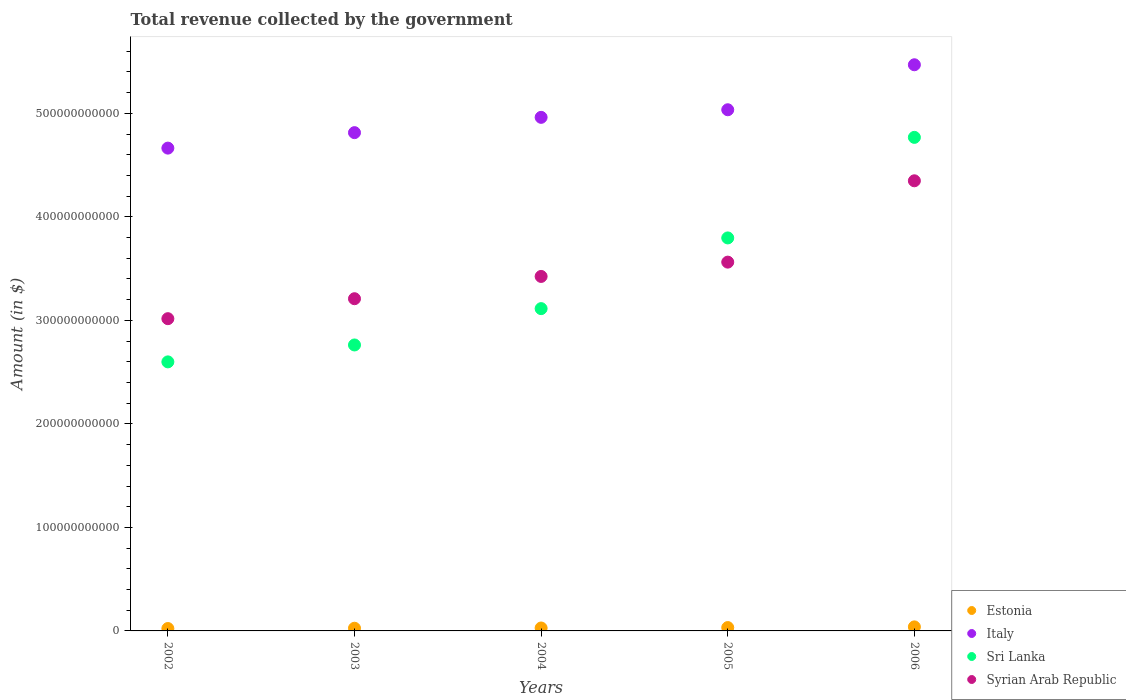How many different coloured dotlines are there?
Ensure brevity in your answer.  4. Is the number of dotlines equal to the number of legend labels?
Give a very brief answer. Yes. What is the total revenue collected by the government in Estonia in 2005?
Give a very brief answer. 3.24e+09. Across all years, what is the maximum total revenue collected by the government in Italy?
Your response must be concise. 5.47e+11. Across all years, what is the minimum total revenue collected by the government in Sri Lanka?
Give a very brief answer. 2.60e+11. In which year was the total revenue collected by the government in Italy maximum?
Provide a succinct answer. 2006. In which year was the total revenue collected by the government in Sri Lanka minimum?
Your answer should be very brief. 2002. What is the total total revenue collected by the government in Italy in the graph?
Your answer should be very brief. 2.49e+12. What is the difference between the total revenue collected by the government in Estonia in 2005 and that in 2006?
Offer a very short reply. -6.53e+08. What is the difference between the total revenue collected by the government in Italy in 2004 and the total revenue collected by the government in Syrian Arab Republic in 2002?
Offer a very short reply. 1.95e+11. What is the average total revenue collected by the government in Sri Lanka per year?
Your answer should be compact. 3.41e+11. In the year 2006, what is the difference between the total revenue collected by the government in Estonia and total revenue collected by the government in Sri Lanka?
Offer a very short reply. -4.73e+11. In how many years, is the total revenue collected by the government in Estonia greater than 40000000000 $?
Provide a succinct answer. 0. What is the ratio of the total revenue collected by the government in Sri Lanka in 2004 to that in 2006?
Give a very brief answer. 0.65. Is the total revenue collected by the government in Syrian Arab Republic in 2003 less than that in 2005?
Ensure brevity in your answer.  Yes. What is the difference between the highest and the second highest total revenue collected by the government in Sri Lanka?
Offer a terse response. 9.72e+1. What is the difference between the highest and the lowest total revenue collected by the government in Estonia?
Ensure brevity in your answer.  1.58e+09. Is the sum of the total revenue collected by the government in Syrian Arab Republic in 2004 and 2006 greater than the maximum total revenue collected by the government in Estonia across all years?
Make the answer very short. Yes. Is the total revenue collected by the government in Italy strictly less than the total revenue collected by the government in Sri Lanka over the years?
Keep it short and to the point. No. What is the difference between two consecutive major ticks on the Y-axis?
Offer a terse response. 1.00e+11. Does the graph contain any zero values?
Your answer should be compact. No. Does the graph contain grids?
Your answer should be compact. No. Where does the legend appear in the graph?
Offer a terse response. Bottom right. How are the legend labels stacked?
Provide a short and direct response. Vertical. What is the title of the graph?
Ensure brevity in your answer.  Total revenue collected by the government. What is the label or title of the Y-axis?
Make the answer very short. Amount (in $). What is the Amount (in $) in Estonia in 2002?
Your response must be concise. 2.32e+09. What is the Amount (in $) in Italy in 2002?
Provide a short and direct response. 4.66e+11. What is the Amount (in $) in Sri Lanka in 2002?
Give a very brief answer. 2.60e+11. What is the Amount (in $) of Syrian Arab Republic in 2002?
Offer a terse response. 3.02e+11. What is the Amount (in $) in Estonia in 2003?
Give a very brief answer. 2.60e+09. What is the Amount (in $) of Italy in 2003?
Your answer should be very brief. 4.81e+11. What is the Amount (in $) in Sri Lanka in 2003?
Give a very brief answer. 2.76e+11. What is the Amount (in $) in Syrian Arab Republic in 2003?
Ensure brevity in your answer.  3.21e+11. What is the Amount (in $) of Estonia in 2004?
Give a very brief answer. 2.83e+09. What is the Amount (in $) of Italy in 2004?
Offer a terse response. 4.96e+11. What is the Amount (in $) in Sri Lanka in 2004?
Your answer should be compact. 3.11e+11. What is the Amount (in $) in Syrian Arab Republic in 2004?
Your answer should be compact. 3.42e+11. What is the Amount (in $) of Estonia in 2005?
Make the answer very short. 3.24e+09. What is the Amount (in $) of Italy in 2005?
Offer a very short reply. 5.03e+11. What is the Amount (in $) in Sri Lanka in 2005?
Provide a short and direct response. 3.80e+11. What is the Amount (in $) of Syrian Arab Republic in 2005?
Your answer should be compact. 3.56e+11. What is the Amount (in $) of Estonia in 2006?
Your response must be concise. 3.90e+09. What is the Amount (in $) of Italy in 2006?
Make the answer very short. 5.47e+11. What is the Amount (in $) of Sri Lanka in 2006?
Your answer should be compact. 4.77e+11. What is the Amount (in $) in Syrian Arab Republic in 2006?
Offer a terse response. 4.35e+11. Across all years, what is the maximum Amount (in $) in Estonia?
Provide a succinct answer. 3.90e+09. Across all years, what is the maximum Amount (in $) in Italy?
Offer a very short reply. 5.47e+11. Across all years, what is the maximum Amount (in $) of Sri Lanka?
Your response must be concise. 4.77e+11. Across all years, what is the maximum Amount (in $) of Syrian Arab Republic?
Make the answer very short. 4.35e+11. Across all years, what is the minimum Amount (in $) of Estonia?
Offer a very short reply. 2.32e+09. Across all years, what is the minimum Amount (in $) in Italy?
Provide a succinct answer. 4.66e+11. Across all years, what is the minimum Amount (in $) of Sri Lanka?
Your answer should be very brief. 2.60e+11. Across all years, what is the minimum Amount (in $) of Syrian Arab Republic?
Ensure brevity in your answer.  3.02e+11. What is the total Amount (in $) in Estonia in the graph?
Make the answer very short. 1.49e+1. What is the total Amount (in $) in Italy in the graph?
Keep it short and to the point. 2.49e+12. What is the total Amount (in $) of Sri Lanka in the graph?
Ensure brevity in your answer.  1.70e+12. What is the total Amount (in $) in Syrian Arab Republic in the graph?
Your response must be concise. 1.76e+12. What is the difference between the Amount (in $) of Estonia in 2002 and that in 2003?
Keep it short and to the point. -2.82e+08. What is the difference between the Amount (in $) of Italy in 2002 and that in 2003?
Provide a short and direct response. -1.50e+1. What is the difference between the Amount (in $) of Sri Lanka in 2002 and that in 2003?
Give a very brief answer. -1.63e+1. What is the difference between the Amount (in $) of Syrian Arab Republic in 2002 and that in 2003?
Provide a short and direct response. -1.93e+1. What is the difference between the Amount (in $) in Estonia in 2002 and that in 2004?
Your answer should be compact. -5.18e+08. What is the difference between the Amount (in $) of Italy in 2002 and that in 2004?
Keep it short and to the point. -2.97e+1. What is the difference between the Amount (in $) of Sri Lanka in 2002 and that in 2004?
Your response must be concise. -5.14e+1. What is the difference between the Amount (in $) of Syrian Arab Republic in 2002 and that in 2004?
Keep it short and to the point. -4.08e+1. What is the difference between the Amount (in $) in Estonia in 2002 and that in 2005?
Provide a succinct answer. -9.29e+08. What is the difference between the Amount (in $) in Italy in 2002 and that in 2005?
Provide a succinct answer. -3.71e+1. What is the difference between the Amount (in $) of Sri Lanka in 2002 and that in 2005?
Give a very brief answer. -1.20e+11. What is the difference between the Amount (in $) in Syrian Arab Republic in 2002 and that in 2005?
Ensure brevity in your answer.  -5.46e+1. What is the difference between the Amount (in $) of Estonia in 2002 and that in 2006?
Offer a terse response. -1.58e+09. What is the difference between the Amount (in $) of Italy in 2002 and that in 2006?
Offer a very short reply. -8.05e+1. What is the difference between the Amount (in $) in Sri Lanka in 2002 and that in 2006?
Offer a very short reply. -2.17e+11. What is the difference between the Amount (in $) in Syrian Arab Republic in 2002 and that in 2006?
Offer a terse response. -1.33e+11. What is the difference between the Amount (in $) in Estonia in 2003 and that in 2004?
Make the answer very short. -2.36e+08. What is the difference between the Amount (in $) of Italy in 2003 and that in 2004?
Give a very brief answer. -1.48e+1. What is the difference between the Amount (in $) in Sri Lanka in 2003 and that in 2004?
Your answer should be compact. -3.51e+1. What is the difference between the Amount (in $) of Syrian Arab Republic in 2003 and that in 2004?
Provide a short and direct response. -2.15e+1. What is the difference between the Amount (in $) of Estonia in 2003 and that in 2005?
Give a very brief answer. -6.47e+08. What is the difference between the Amount (in $) in Italy in 2003 and that in 2005?
Your response must be concise. -2.21e+1. What is the difference between the Amount (in $) of Sri Lanka in 2003 and that in 2005?
Give a very brief answer. -1.03e+11. What is the difference between the Amount (in $) of Syrian Arab Republic in 2003 and that in 2005?
Keep it short and to the point. -3.54e+1. What is the difference between the Amount (in $) in Estonia in 2003 and that in 2006?
Keep it short and to the point. -1.30e+09. What is the difference between the Amount (in $) in Italy in 2003 and that in 2006?
Ensure brevity in your answer.  -6.56e+1. What is the difference between the Amount (in $) of Sri Lanka in 2003 and that in 2006?
Offer a terse response. -2.01e+11. What is the difference between the Amount (in $) in Syrian Arab Republic in 2003 and that in 2006?
Provide a short and direct response. -1.14e+11. What is the difference between the Amount (in $) of Estonia in 2004 and that in 2005?
Give a very brief answer. -4.11e+08. What is the difference between the Amount (in $) in Italy in 2004 and that in 2005?
Provide a short and direct response. -7.33e+09. What is the difference between the Amount (in $) in Sri Lanka in 2004 and that in 2005?
Offer a terse response. -6.83e+1. What is the difference between the Amount (in $) of Syrian Arab Republic in 2004 and that in 2005?
Give a very brief answer. -1.38e+1. What is the difference between the Amount (in $) in Estonia in 2004 and that in 2006?
Provide a succinct answer. -1.06e+09. What is the difference between the Amount (in $) in Italy in 2004 and that in 2006?
Make the answer very short. -5.08e+1. What is the difference between the Amount (in $) in Sri Lanka in 2004 and that in 2006?
Your answer should be very brief. -1.65e+11. What is the difference between the Amount (in $) in Syrian Arab Republic in 2004 and that in 2006?
Give a very brief answer. -9.24e+1. What is the difference between the Amount (in $) of Estonia in 2005 and that in 2006?
Ensure brevity in your answer.  -6.53e+08. What is the difference between the Amount (in $) in Italy in 2005 and that in 2006?
Give a very brief answer. -4.35e+1. What is the difference between the Amount (in $) of Sri Lanka in 2005 and that in 2006?
Provide a succinct answer. -9.72e+1. What is the difference between the Amount (in $) in Syrian Arab Republic in 2005 and that in 2006?
Your answer should be compact. -7.86e+1. What is the difference between the Amount (in $) of Estonia in 2002 and the Amount (in $) of Italy in 2003?
Provide a short and direct response. -4.79e+11. What is the difference between the Amount (in $) in Estonia in 2002 and the Amount (in $) in Sri Lanka in 2003?
Ensure brevity in your answer.  -2.74e+11. What is the difference between the Amount (in $) in Estonia in 2002 and the Amount (in $) in Syrian Arab Republic in 2003?
Offer a terse response. -3.19e+11. What is the difference between the Amount (in $) of Italy in 2002 and the Amount (in $) of Sri Lanka in 2003?
Give a very brief answer. 1.90e+11. What is the difference between the Amount (in $) of Italy in 2002 and the Amount (in $) of Syrian Arab Republic in 2003?
Your answer should be compact. 1.45e+11. What is the difference between the Amount (in $) in Sri Lanka in 2002 and the Amount (in $) in Syrian Arab Republic in 2003?
Make the answer very short. -6.10e+1. What is the difference between the Amount (in $) of Estonia in 2002 and the Amount (in $) of Italy in 2004?
Your answer should be compact. -4.94e+11. What is the difference between the Amount (in $) of Estonia in 2002 and the Amount (in $) of Sri Lanka in 2004?
Make the answer very short. -3.09e+11. What is the difference between the Amount (in $) of Estonia in 2002 and the Amount (in $) of Syrian Arab Republic in 2004?
Ensure brevity in your answer.  -3.40e+11. What is the difference between the Amount (in $) in Italy in 2002 and the Amount (in $) in Sri Lanka in 2004?
Your answer should be compact. 1.55e+11. What is the difference between the Amount (in $) of Italy in 2002 and the Amount (in $) of Syrian Arab Republic in 2004?
Your response must be concise. 1.24e+11. What is the difference between the Amount (in $) of Sri Lanka in 2002 and the Amount (in $) of Syrian Arab Republic in 2004?
Your response must be concise. -8.25e+1. What is the difference between the Amount (in $) in Estonia in 2002 and the Amount (in $) in Italy in 2005?
Provide a succinct answer. -5.01e+11. What is the difference between the Amount (in $) of Estonia in 2002 and the Amount (in $) of Sri Lanka in 2005?
Provide a succinct answer. -3.77e+11. What is the difference between the Amount (in $) of Estonia in 2002 and the Amount (in $) of Syrian Arab Republic in 2005?
Provide a succinct answer. -3.54e+11. What is the difference between the Amount (in $) of Italy in 2002 and the Amount (in $) of Sri Lanka in 2005?
Your answer should be compact. 8.68e+1. What is the difference between the Amount (in $) in Italy in 2002 and the Amount (in $) in Syrian Arab Republic in 2005?
Provide a succinct answer. 1.10e+11. What is the difference between the Amount (in $) of Sri Lanka in 2002 and the Amount (in $) of Syrian Arab Republic in 2005?
Give a very brief answer. -9.64e+1. What is the difference between the Amount (in $) in Estonia in 2002 and the Amount (in $) in Italy in 2006?
Make the answer very short. -5.45e+11. What is the difference between the Amount (in $) in Estonia in 2002 and the Amount (in $) in Sri Lanka in 2006?
Your response must be concise. -4.75e+11. What is the difference between the Amount (in $) of Estonia in 2002 and the Amount (in $) of Syrian Arab Republic in 2006?
Give a very brief answer. -4.33e+11. What is the difference between the Amount (in $) in Italy in 2002 and the Amount (in $) in Sri Lanka in 2006?
Provide a short and direct response. -1.04e+1. What is the difference between the Amount (in $) in Italy in 2002 and the Amount (in $) in Syrian Arab Republic in 2006?
Offer a terse response. 3.16e+1. What is the difference between the Amount (in $) in Sri Lanka in 2002 and the Amount (in $) in Syrian Arab Republic in 2006?
Offer a very short reply. -1.75e+11. What is the difference between the Amount (in $) in Estonia in 2003 and the Amount (in $) in Italy in 2004?
Your answer should be very brief. -4.94e+11. What is the difference between the Amount (in $) of Estonia in 2003 and the Amount (in $) of Sri Lanka in 2004?
Give a very brief answer. -3.09e+11. What is the difference between the Amount (in $) in Estonia in 2003 and the Amount (in $) in Syrian Arab Republic in 2004?
Offer a very short reply. -3.40e+11. What is the difference between the Amount (in $) of Italy in 2003 and the Amount (in $) of Sri Lanka in 2004?
Your response must be concise. 1.70e+11. What is the difference between the Amount (in $) of Italy in 2003 and the Amount (in $) of Syrian Arab Republic in 2004?
Give a very brief answer. 1.39e+11. What is the difference between the Amount (in $) in Sri Lanka in 2003 and the Amount (in $) in Syrian Arab Republic in 2004?
Offer a terse response. -6.62e+1. What is the difference between the Amount (in $) of Estonia in 2003 and the Amount (in $) of Italy in 2005?
Keep it short and to the point. -5.01e+11. What is the difference between the Amount (in $) in Estonia in 2003 and the Amount (in $) in Sri Lanka in 2005?
Make the answer very short. -3.77e+11. What is the difference between the Amount (in $) of Estonia in 2003 and the Amount (in $) of Syrian Arab Republic in 2005?
Offer a terse response. -3.54e+11. What is the difference between the Amount (in $) of Italy in 2003 and the Amount (in $) of Sri Lanka in 2005?
Provide a succinct answer. 1.02e+11. What is the difference between the Amount (in $) of Italy in 2003 and the Amount (in $) of Syrian Arab Republic in 2005?
Your answer should be very brief. 1.25e+11. What is the difference between the Amount (in $) in Sri Lanka in 2003 and the Amount (in $) in Syrian Arab Republic in 2005?
Make the answer very short. -8.00e+1. What is the difference between the Amount (in $) of Estonia in 2003 and the Amount (in $) of Italy in 2006?
Make the answer very short. -5.44e+11. What is the difference between the Amount (in $) of Estonia in 2003 and the Amount (in $) of Sri Lanka in 2006?
Make the answer very short. -4.74e+11. What is the difference between the Amount (in $) of Estonia in 2003 and the Amount (in $) of Syrian Arab Republic in 2006?
Provide a succinct answer. -4.32e+11. What is the difference between the Amount (in $) of Italy in 2003 and the Amount (in $) of Sri Lanka in 2006?
Your answer should be very brief. 4.56e+09. What is the difference between the Amount (in $) of Italy in 2003 and the Amount (in $) of Syrian Arab Republic in 2006?
Provide a short and direct response. 4.65e+1. What is the difference between the Amount (in $) of Sri Lanka in 2003 and the Amount (in $) of Syrian Arab Republic in 2006?
Offer a terse response. -1.59e+11. What is the difference between the Amount (in $) of Estonia in 2004 and the Amount (in $) of Italy in 2005?
Your answer should be compact. -5.01e+11. What is the difference between the Amount (in $) in Estonia in 2004 and the Amount (in $) in Sri Lanka in 2005?
Provide a short and direct response. -3.77e+11. What is the difference between the Amount (in $) in Estonia in 2004 and the Amount (in $) in Syrian Arab Republic in 2005?
Your answer should be very brief. -3.53e+11. What is the difference between the Amount (in $) in Italy in 2004 and the Amount (in $) in Sri Lanka in 2005?
Make the answer very short. 1.16e+11. What is the difference between the Amount (in $) of Italy in 2004 and the Amount (in $) of Syrian Arab Republic in 2005?
Your answer should be very brief. 1.40e+11. What is the difference between the Amount (in $) in Sri Lanka in 2004 and the Amount (in $) in Syrian Arab Republic in 2005?
Provide a short and direct response. -4.49e+1. What is the difference between the Amount (in $) of Estonia in 2004 and the Amount (in $) of Italy in 2006?
Provide a succinct answer. -5.44e+11. What is the difference between the Amount (in $) of Estonia in 2004 and the Amount (in $) of Sri Lanka in 2006?
Provide a succinct answer. -4.74e+11. What is the difference between the Amount (in $) of Estonia in 2004 and the Amount (in $) of Syrian Arab Republic in 2006?
Ensure brevity in your answer.  -4.32e+11. What is the difference between the Amount (in $) of Italy in 2004 and the Amount (in $) of Sri Lanka in 2006?
Ensure brevity in your answer.  1.93e+1. What is the difference between the Amount (in $) of Italy in 2004 and the Amount (in $) of Syrian Arab Republic in 2006?
Your answer should be very brief. 6.13e+1. What is the difference between the Amount (in $) of Sri Lanka in 2004 and the Amount (in $) of Syrian Arab Republic in 2006?
Make the answer very short. -1.23e+11. What is the difference between the Amount (in $) in Estonia in 2005 and the Amount (in $) in Italy in 2006?
Keep it short and to the point. -5.44e+11. What is the difference between the Amount (in $) of Estonia in 2005 and the Amount (in $) of Sri Lanka in 2006?
Ensure brevity in your answer.  -4.74e+11. What is the difference between the Amount (in $) of Estonia in 2005 and the Amount (in $) of Syrian Arab Republic in 2006?
Offer a terse response. -4.32e+11. What is the difference between the Amount (in $) in Italy in 2005 and the Amount (in $) in Sri Lanka in 2006?
Make the answer very short. 2.67e+1. What is the difference between the Amount (in $) in Italy in 2005 and the Amount (in $) in Syrian Arab Republic in 2006?
Keep it short and to the point. 6.86e+1. What is the difference between the Amount (in $) of Sri Lanka in 2005 and the Amount (in $) of Syrian Arab Republic in 2006?
Give a very brief answer. -5.52e+1. What is the average Amount (in $) of Estonia per year?
Ensure brevity in your answer.  2.98e+09. What is the average Amount (in $) in Italy per year?
Keep it short and to the point. 4.99e+11. What is the average Amount (in $) in Sri Lanka per year?
Offer a very short reply. 3.41e+11. What is the average Amount (in $) in Syrian Arab Republic per year?
Give a very brief answer. 3.51e+11. In the year 2002, what is the difference between the Amount (in $) in Estonia and Amount (in $) in Italy?
Make the answer very short. -4.64e+11. In the year 2002, what is the difference between the Amount (in $) of Estonia and Amount (in $) of Sri Lanka?
Make the answer very short. -2.58e+11. In the year 2002, what is the difference between the Amount (in $) of Estonia and Amount (in $) of Syrian Arab Republic?
Ensure brevity in your answer.  -2.99e+11. In the year 2002, what is the difference between the Amount (in $) in Italy and Amount (in $) in Sri Lanka?
Make the answer very short. 2.07e+11. In the year 2002, what is the difference between the Amount (in $) of Italy and Amount (in $) of Syrian Arab Republic?
Your answer should be very brief. 1.65e+11. In the year 2002, what is the difference between the Amount (in $) of Sri Lanka and Amount (in $) of Syrian Arab Republic?
Your response must be concise. -4.17e+1. In the year 2003, what is the difference between the Amount (in $) of Estonia and Amount (in $) of Italy?
Provide a short and direct response. -4.79e+11. In the year 2003, what is the difference between the Amount (in $) in Estonia and Amount (in $) in Sri Lanka?
Your answer should be compact. -2.74e+11. In the year 2003, what is the difference between the Amount (in $) of Estonia and Amount (in $) of Syrian Arab Republic?
Make the answer very short. -3.18e+11. In the year 2003, what is the difference between the Amount (in $) in Italy and Amount (in $) in Sri Lanka?
Offer a very short reply. 2.05e+11. In the year 2003, what is the difference between the Amount (in $) in Italy and Amount (in $) in Syrian Arab Republic?
Keep it short and to the point. 1.60e+11. In the year 2003, what is the difference between the Amount (in $) in Sri Lanka and Amount (in $) in Syrian Arab Republic?
Make the answer very short. -4.47e+1. In the year 2004, what is the difference between the Amount (in $) of Estonia and Amount (in $) of Italy?
Provide a succinct answer. -4.93e+11. In the year 2004, what is the difference between the Amount (in $) in Estonia and Amount (in $) in Sri Lanka?
Ensure brevity in your answer.  -3.09e+11. In the year 2004, what is the difference between the Amount (in $) of Estonia and Amount (in $) of Syrian Arab Republic?
Your answer should be very brief. -3.40e+11. In the year 2004, what is the difference between the Amount (in $) of Italy and Amount (in $) of Sri Lanka?
Ensure brevity in your answer.  1.85e+11. In the year 2004, what is the difference between the Amount (in $) in Italy and Amount (in $) in Syrian Arab Republic?
Your response must be concise. 1.54e+11. In the year 2004, what is the difference between the Amount (in $) of Sri Lanka and Amount (in $) of Syrian Arab Republic?
Your answer should be very brief. -3.11e+1. In the year 2005, what is the difference between the Amount (in $) of Estonia and Amount (in $) of Italy?
Provide a succinct answer. -5.00e+11. In the year 2005, what is the difference between the Amount (in $) in Estonia and Amount (in $) in Sri Lanka?
Offer a very short reply. -3.76e+11. In the year 2005, what is the difference between the Amount (in $) in Estonia and Amount (in $) in Syrian Arab Republic?
Your answer should be compact. -3.53e+11. In the year 2005, what is the difference between the Amount (in $) of Italy and Amount (in $) of Sri Lanka?
Provide a short and direct response. 1.24e+11. In the year 2005, what is the difference between the Amount (in $) in Italy and Amount (in $) in Syrian Arab Republic?
Give a very brief answer. 1.47e+11. In the year 2005, what is the difference between the Amount (in $) of Sri Lanka and Amount (in $) of Syrian Arab Republic?
Your response must be concise. 2.34e+1. In the year 2006, what is the difference between the Amount (in $) in Estonia and Amount (in $) in Italy?
Make the answer very short. -5.43e+11. In the year 2006, what is the difference between the Amount (in $) in Estonia and Amount (in $) in Sri Lanka?
Make the answer very short. -4.73e+11. In the year 2006, what is the difference between the Amount (in $) of Estonia and Amount (in $) of Syrian Arab Republic?
Ensure brevity in your answer.  -4.31e+11. In the year 2006, what is the difference between the Amount (in $) of Italy and Amount (in $) of Sri Lanka?
Offer a very short reply. 7.01e+1. In the year 2006, what is the difference between the Amount (in $) of Italy and Amount (in $) of Syrian Arab Republic?
Offer a terse response. 1.12e+11. In the year 2006, what is the difference between the Amount (in $) in Sri Lanka and Amount (in $) in Syrian Arab Republic?
Your answer should be very brief. 4.20e+1. What is the ratio of the Amount (in $) of Estonia in 2002 to that in 2003?
Give a very brief answer. 0.89. What is the ratio of the Amount (in $) of Italy in 2002 to that in 2003?
Ensure brevity in your answer.  0.97. What is the ratio of the Amount (in $) in Sri Lanka in 2002 to that in 2003?
Ensure brevity in your answer.  0.94. What is the ratio of the Amount (in $) of Syrian Arab Republic in 2002 to that in 2003?
Your answer should be compact. 0.94. What is the ratio of the Amount (in $) of Estonia in 2002 to that in 2004?
Keep it short and to the point. 0.82. What is the ratio of the Amount (in $) of Italy in 2002 to that in 2004?
Provide a succinct answer. 0.94. What is the ratio of the Amount (in $) in Sri Lanka in 2002 to that in 2004?
Ensure brevity in your answer.  0.83. What is the ratio of the Amount (in $) in Syrian Arab Republic in 2002 to that in 2004?
Your answer should be very brief. 0.88. What is the ratio of the Amount (in $) of Estonia in 2002 to that in 2005?
Your response must be concise. 0.71. What is the ratio of the Amount (in $) of Italy in 2002 to that in 2005?
Make the answer very short. 0.93. What is the ratio of the Amount (in $) in Sri Lanka in 2002 to that in 2005?
Ensure brevity in your answer.  0.68. What is the ratio of the Amount (in $) in Syrian Arab Republic in 2002 to that in 2005?
Offer a very short reply. 0.85. What is the ratio of the Amount (in $) of Estonia in 2002 to that in 2006?
Provide a succinct answer. 0.59. What is the ratio of the Amount (in $) of Italy in 2002 to that in 2006?
Provide a succinct answer. 0.85. What is the ratio of the Amount (in $) in Sri Lanka in 2002 to that in 2006?
Offer a terse response. 0.55. What is the ratio of the Amount (in $) in Syrian Arab Republic in 2002 to that in 2006?
Provide a succinct answer. 0.69. What is the ratio of the Amount (in $) of Estonia in 2003 to that in 2004?
Your answer should be compact. 0.92. What is the ratio of the Amount (in $) in Italy in 2003 to that in 2004?
Make the answer very short. 0.97. What is the ratio of the Amount (in $) of Sri Lanka in 2003 to that in 2004?
Your answer should be compact. 0.89. What is the ratio of the Amount (in $) of Syrian Arab Republic in 2003 to that in 2004?
Your answer should be very brief. 0.94. What is the ratio of the Amount (in $) of Estonia in 2003 to that in 2005?
Your answer should be compact. 0.8. What is the ratio of the Amount (in $) of Italy in 2003 to that in 2005?
Provide a short and direct response. 0.96. What is the ratio of the Amount (in $) of Sri Lanka in 2003 to that in 2005?
Keep it short and to the point. 0.73. What is the ratio of the Amount (in $) of Syrian Arab Republic in 2003 to that in 2005?
Make the answer very short. 0.9. What is the ratio of the Amount (in $) of Estonia in 2003 to that in 2006?
Make the answer very short. 0.67. What is the ratio of the Amount (in $) of Italy in 2003 to that in 2006?
Offer a terse response. 0.88. What is the ratio of the Amount (in $) of Sri Lanka in 2003 to that in 2006?
Give a very brief answer. 0.58. What is the ratio of the Amount (in $) of Syrian Arab Republic in 2003 to that in 2006?
Ensure brevity in your answer.  0.74. What is the ratio of the Amount (in $) of Estonia in 2004 to that in 2005?
Your answer should be very brief. 0.87. What is the ratio of the Amount (in $) of Italy in 2004 to that in 2005?
Provide a short and direct response. 0.99. What is the ratio of the Amount (in $) in Sri Lanka in 2004 to that in 2005?
Keep it short and to the point. 0.82. What is the ratio of the Amount (in $) in Syrian Arab Republic in 2004 to that in 2005?
Your response must be concise. 0.96. What is the ratio of the Amount (in $) of Estonia in 2004 to that in 2006?
Your response must be concise. 0.73. What is the ratio of the Amount (in $) of Italy in 2004 to that in 2006?
Make the answer very short. 0.91. What is the ratio of the Amount (in $) of Sri Lanka in 2004 to that in 2006?
Give a very brief answer. 0.65. What is the ratio of the Amount (in $) in Syrian Arab Republic in 2004 to that in 2006?
Give a very brief answer. 0.79. What is the ratio of the Amount (in $) of Estonia in 2005 to that in 2006?
Your answer should be very brief. 0.83. What is the ratio of the Amount (in $) in Italy in 2005 to that in 2006?
Your answer should be very brief. 0.92. What is the ratio of the Amount (in $) in Sri Lanka in 2005 to that in 2006?
Make the answer very short. 0.8. What is the ratio of the Amount (in $) of Syrian Arab Republic in 2005 to that in 2006?
Keep it short and to the point. 0.82. What is the difference between the highest and the second highest Amount (in $) in Estonia?
Offer a terse response. 6.53e+08. What is the difference between the highest and the second highest Amount (in $) of Italy?
Make the answer very short. 4.35e+1. What is the difference between the highest and the second highest Amount (in $) in Sri Lanka?
Your answer should be compact. 9.72e+1. What is the difference between the highest and the second highest Amount (in $) in Syrian Arab Republic?
Keep it short and to the point. 7.86e+1. What is the difference between the highest and the lowest Amount (in $) of Estonia?
Your response must be concise. 1.58e+09. What is the difference between the highest and the lowest Amount (in $) of Italy?
Provide a succinct answer. 8.05e+1. What is the difference between the highest and the lowest Amount (in $) of Sri Lanka?
Your answer should be compact. 2.17e+11. What is the difference between the highest and the lowest Amount (in $) in Syrian Arab Republic?
Keep it short and to the point. 1.33e+11. 